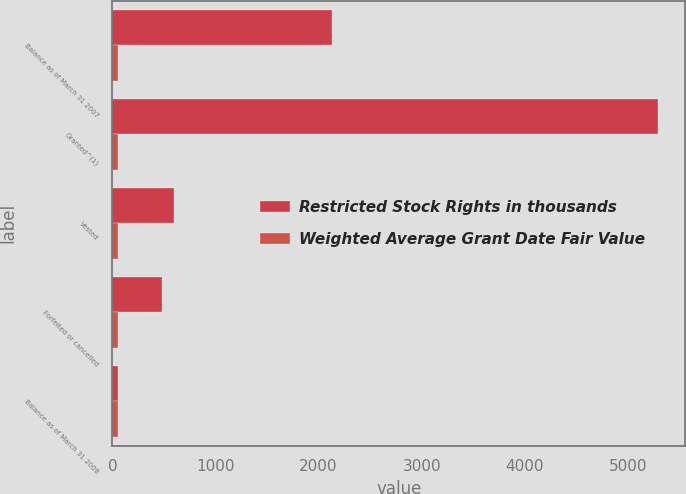Convert chart. <chart><loc_0><loc_0><loc_500><loc_500><stacked_bar_chart><ecel><fcel>Balance as of March 31 2007<fcel>Granted^(1)<fcel>Vested<fcel>Forfeited or cancelled<fcel>Balance as of March 31 2008<nl><fcel>Restricted Stock Rights in thousands<fcel>2134<fcel>5293<fcel>597<fcel>486<fcel>52.62<nl><fcel>Weighted Average Grant Date Fair Value<fcel>52.62<fcel>52.06<fcel>52.46<fcel>51.99<fcel>52.22<nl></chart> 